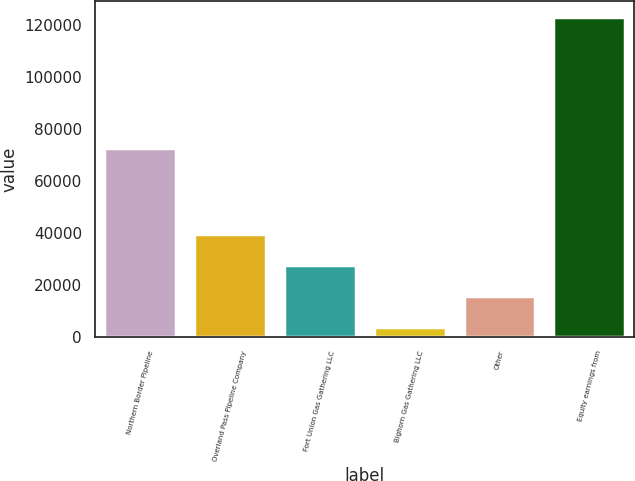Convert chart. <chart><loc_0><loc_0><loc_500><loc_500><bar_chart><fcel>Northern Border Pipeline<fcel>Overland Pass Pipeline Company<fcel>Fort Union Gas Gathering LLC<fcel>Bighorn Gas Gathering LLC<fcel>Other<fcel>Equity earnings from<nl><fcel>72705<fcel>39581.2<fcel>27660.8<fcel>3820<fcel>15740.4<fcel>123024<nl></chart> 